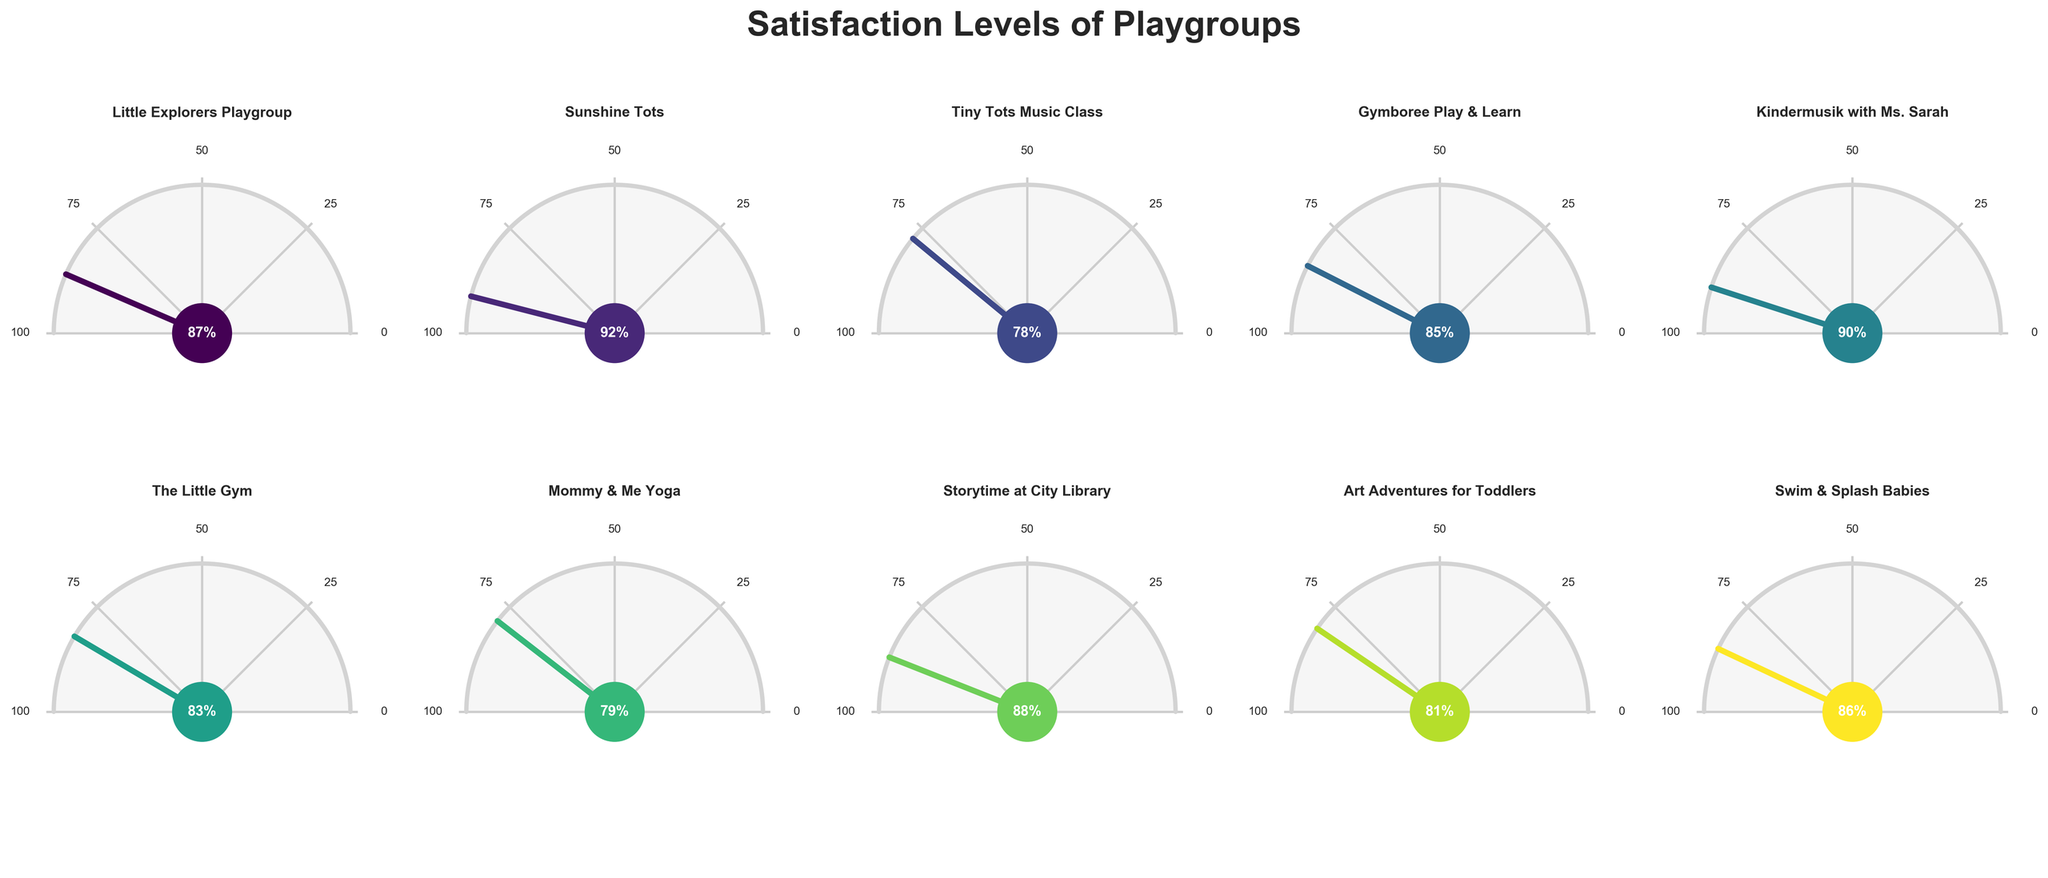How many playgroups are displayed in the figure? The figure consists of 10 gauge charts representing satisfaction levels for different playgroups. Each playgroup has its own gauge chart. Counting and verifying the gauge charts confirms this.
Answer: 10 Which playgroup received the highest satisfaction level? The playgroup with the highest satisfaction is identified by looking at the gauge charts and comparing satisfaction percentages. Sunshine Tots has the highest satisfaction at 92%.
Answer: Sunshine Tots What is the difference in satisfaction between Gymboree Play & Learn and Tiny Tots Music Class? Gymboree Play & Learn has a satisfaction level of 85%, while Tiny Tots Music Class has a satisfaction level of 78%. The difference is calculated as 85 - 78 = 7.
Answer: 7% What is the average satisfaction level of all the playgroups? Add all satisfaction levels: 87 + 92 + 78 + 85 + 90 + 83 + 79 + 88 + 81 + 86 = 849. There are 10 playgroups, so the average is 849 / 10 = 84.9.
Answer: 84.9% Which playgroup has the lowest satisfaction? The playgroup with the lowest satisfaction is Tiny Tots Music Class at 78%, as seen by comparing all the displayed satisfaction percentages.
Answer: Tiny Tots Music Class Are there any playgroups with a satisfaction level between 80% and 85%? Checking the satisfaction percentages, Art Adventures for Toddlers has 81%, The Little Gym has 83%, and Gymboree Play & Learn has 85%. These are within the 80%-85% range.
Answer: Yes What is the total satisfaction for Sunshine Tots and Storytime at City Library combined? Sunshine Tots has 92% and Storytime at City Library has 88%. Adding them together gives 92 + 88 = 180.
Answer: 180% Is the satisfaction level of Kindermusik with Ms. Sarah higher or lower than Mommy & Me Yoga? Kindermusik with Ms. Sarah has a satisfaction level of 90%, while Mommy & Me Yoga has 79%. Comparing these, 90% is higher than 79%.
Answer: Higher Which playgroup has a satisfaction level closest to the overall average? The overall average satisfaction level is 84.9%. Among the playgroups, Gymboree Play & Learn with 85% is closest to this average.
Answer: Gymboree Play & Learn 